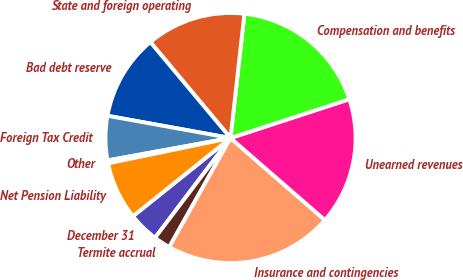<chart> <loc_0><loc_0><loc_500><loc_500><pie_chart><fcel>December 31<fcel>Termite accrual<fcel>Insurance and contingencies<fcel>Unearned revenues<fcel>Compensation and benefits<fcel>State and foreign operating<fcel>Bad debt reserve<fcel>Foreign Tax Credit<fcel>Other<fcel>Net Pension Liability<nl><fcel>3.94%<fcel>2.16%<fcel>21.76%<fcel>16.42%<fcel>18.2%<fcel>12.85%<fcel>11.07%<fcel>5.72%<fcel>0.38%<fcel>7.5%<nl></chart> 